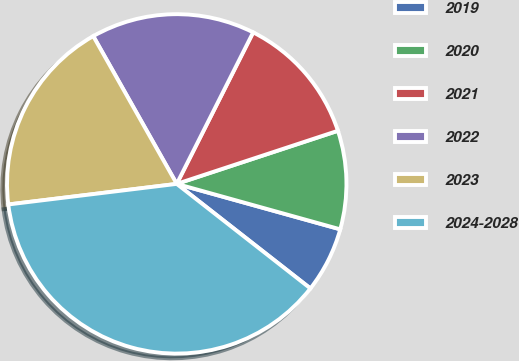<chart> <loc_0><loc_0><loc_500><loc_500><pie_chart><fcel>2019<fcel>2020<fcel>2021<fcel>2022<fcel>2023<fcel>2024-2028<nl><fcel>6.25%<fcel>9.38%<fcel>12.5%<fcel>15.62%<fcel>18.75%<fcel>37.5%<nl></chart> 